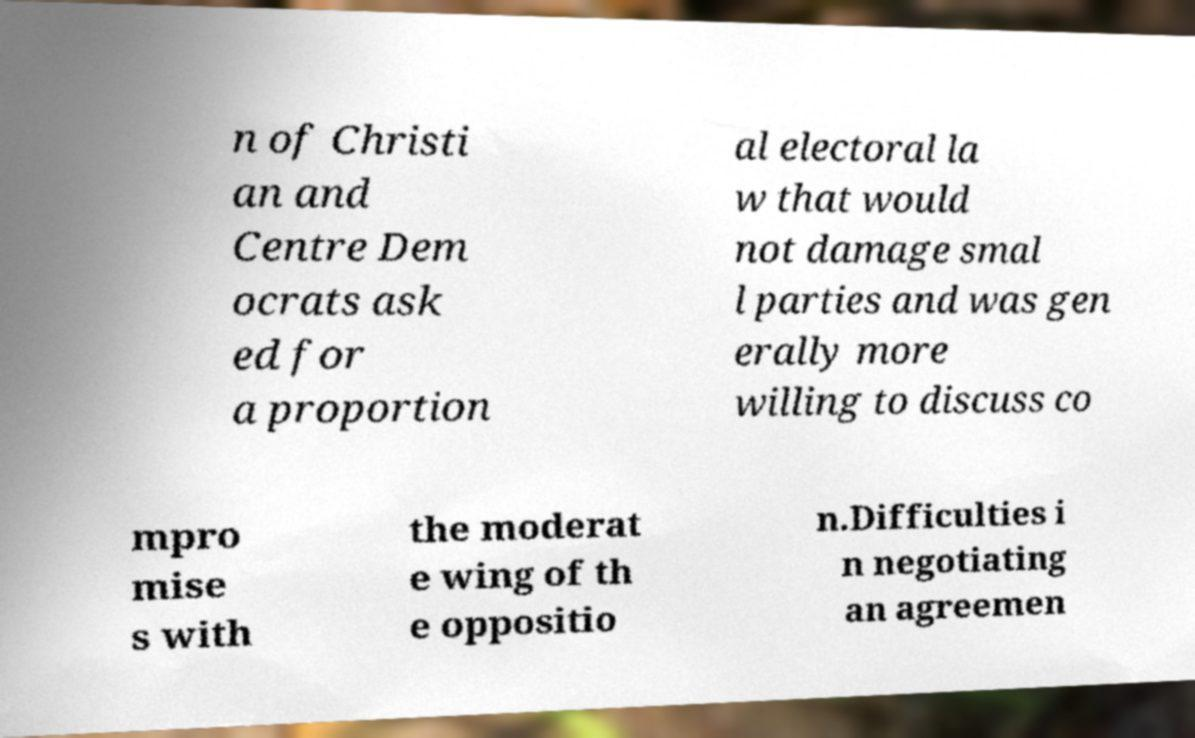Please read and relay the text visible in this image. What does it say? n of Christi an and Centre Dem ocrats ask ed for a proportion al electoral la w that would not damage smal l parties and was gen erally more willing to discuss co mpro mise s with the moderat e wing of th e oppositio n.Difficulties i n negotiating an agreemen 